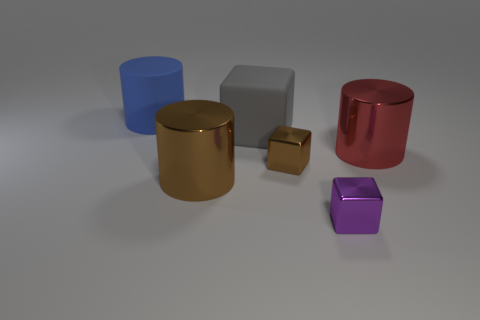Are there an equal number of large brown metallic objects behind the small purple metallic block and tiny brown spheres?
Your answer should be very brief. No. How many cylinders are on the left side of the large matte cube?
Give a very brief answer. 2. The rubber cube has what size?
Provide a short and direct response. Large. What color is the other big cylinder that is the same material as the red cylinder?
Provide a succinct answer. Brown. How many blocks are the same size as the blue object?
Your response must be concise. 1. Is the material of the big thing that is in front of the big red object the same as the tiny purple object?
Give a very brief answer. Yes. Is the number of tiny metallic cubes behind the red cylinder less than the number of purple metallic things?
Provide a short and direct response. Yes. There is a big metal thing that is on the left side of the gray rubber block; what shape is it?
Ensure brevity in your answer.  Cylinder. What is the shape of the brown thing that is the same size as the gray block?
Make the answer very short. Cylinder. Is there a large blue thing that has the same shape as the gray thing?
Provide a succinct answer. No. 